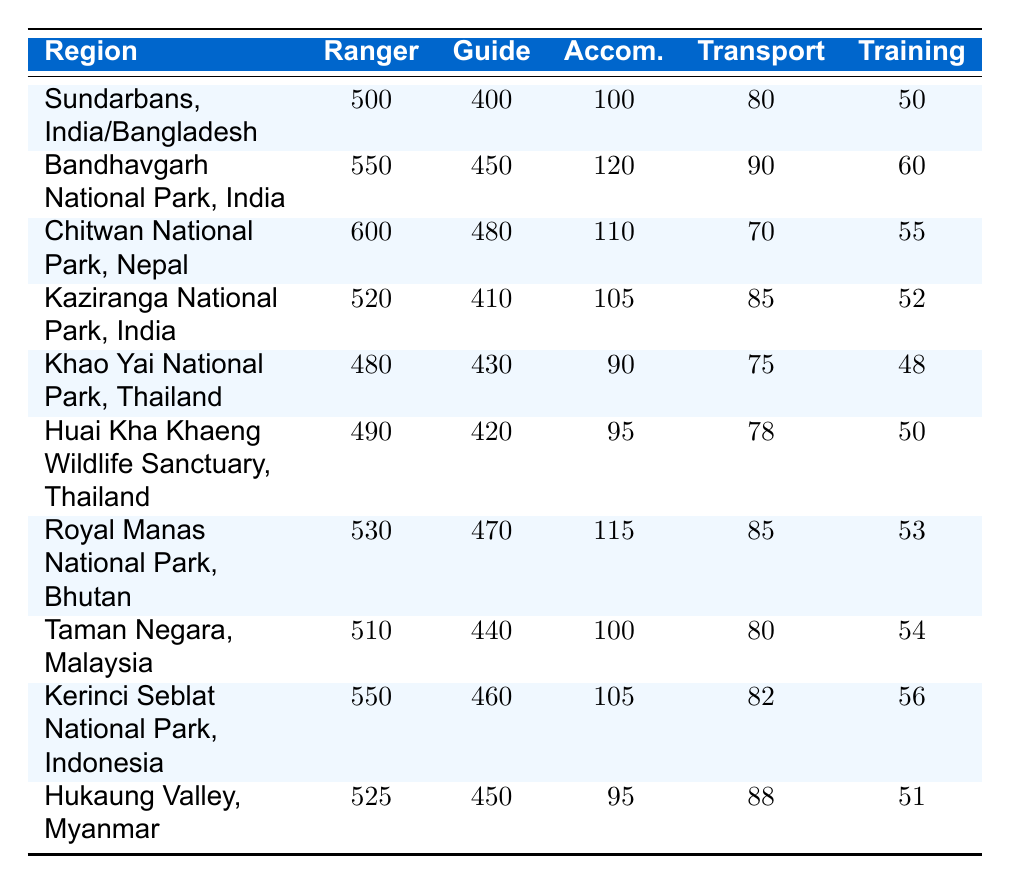What is the highest ranger cost per month? By reviewing the ranger costs column, I can see that Chitwan National Park, Nepal has the highest ranger cost listed at 600 USD per month.
Answer: 600 What is the total guide cost for Sundarbans, India/Bangladesh, and Khao Yai National Park, Thailand? The guide cost for Sundarbans is 400 USD and for Khao Yai National Park is 430 USD. I add these two amounts: 400 + 430 = 830 USD.
Answer: 830 Is the transportation cost in Bandhavgarh National Park higher than in Huai Kha Khaeng Wildlife Sanctuary? The transportation cost for Bandhavgarh National Park is 90 USD while for Huai Kha Khaeng Wildlife Sanctuary, it is 78 USD. Since 90 is greater than 78, it is true that Bandhavgarh's transportation cost is higher.
Answer: Yes What is the average accommodation cost across all regions? I will sum up the accommodation costs: 100 + 120 + 110 + 105 + 90 + 95 + 115 + 100 + 105 + 95 = 1,025 USD. Then I divide by the number of regions, which is 10: 1,025/10 = 102.5 USD.
Answer: 102.5 Which region has the lowest total cost when combining ranger, guide, accommodation, transportation, and training costs? To find this, I calculate the total costs for each region, which involves adding all five costs together for each. Sundarbans: 500 + 400 + 100 + 80 + 50 = 1130; Bandhavgarh: 550 + 450 + 120 + 90 + 60 = 1270; Chitwan: 600 + 480 + 110 + 70 + 55 = 1,415; Kaziranga: 520 + 410 + 105 + 85 + 52 = 1,172; Khao Yai: 480 + 430 + 90 + 75 + 48 = 1,123; Huai Kha Khaeng: 490 + 420 + 95 + 78 + 50 = 1,133; Royal Manas: 530 + 470 + 115 + 85 + 53 = 1,253; Taman Negara: 510 + 440 + 100 + 80 + 54 = 1,184; Kerinci Seblat: 550 + 460 + 105 + 82 + 56 = 1,253; Hukaung Valley: 525 + 450 + 95 + 88 + 51 = 1,209. The lowest total cost is found in Khao Yai National Park, totaling 1,123 USD.
Answer: Khao Yai National Park Is the total cost of rangers in Hukaung Valley, Myanmar more than in Kaziranga National Park, India? The total ranger costs are 525 USD for Hukaung Valley and 520 USD for Kaziranga. Since 525 is greater than 520, the answer is yes.
Answer: Yes 